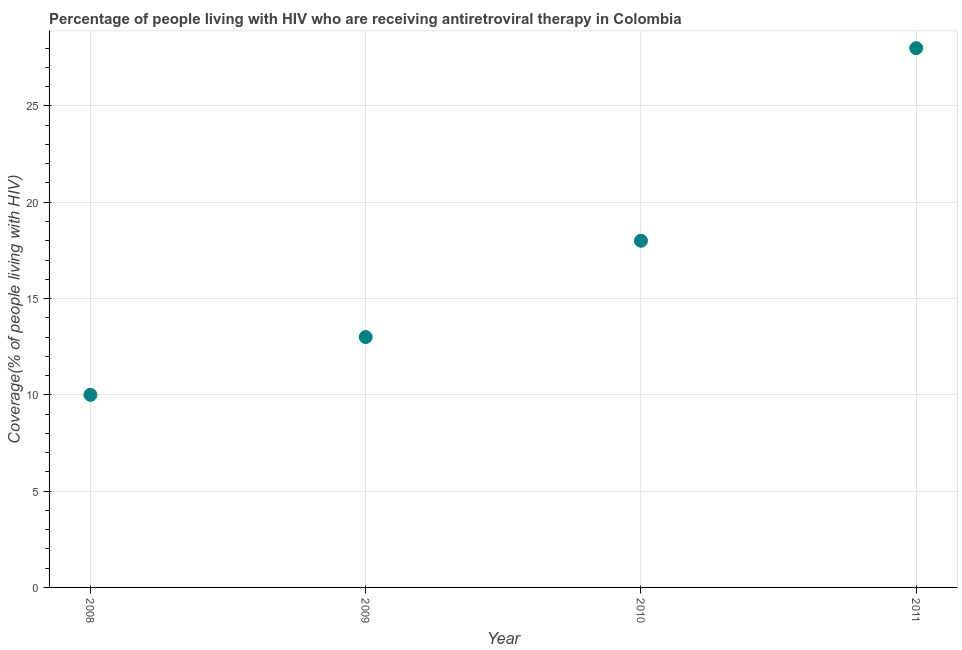What is the antiretroviral therapy coverage in 2008?
Your answer should be compact. 10. Across all years, what is the maximum antiretroviral therapy coverage?
Your answer should be compact. 28. Across all years, what is the minimum antiretroviral therapy coverage?
Offer a terse response. 10. What is the sum of the antiretroviral therapy coverage?
Keep it short and to the point. 69. What is the difference between the antiretroviral therapy coverage in 2008 and 2009?
Offer a terse response. -3. What is the average antiretroviral therapy coverage per year?
Make the answer very short. 17.25. What is the median antiretroviral therapy coverage?
Your answer should be very brief. 15.5. Do a majority of the years between 2010 and 2011 (inclusive) have antiretroviral therapy coverage greater than 18 %?
Offer a terse response. No. What is the ratio of the antiretroviral therapy coverage in 2008 to that in 2010?
Offer a very short reply. 0.56. Is the difference between the antiretroviral therapy coverage in 2008 and 2011 greater than the difference between any two years?
Ensure brevity in your answer.  Yes. What is the difference between the highest and the second highest antiretroviral therapy coverage?
Provide a succinct answer. 10. What is the difference between the highest and the lowest antiretroviral therapy coverage?
Provide a succinct answer. 18. Does the antiretroviral therapy coverage monotonically increase over the years?
Offer a terse response. Yes. How many dotlines are there?
Your answer should be very brief. 1. What is the difference between two consecutive major ticks on the Y-axis?
Your answer should be very brief. 5. Are the values on the major ticks of Y-axis written in scientific E-notation?
Ensure brevity in your answer.  No. Does the graph contain any zero values?
Your response must be concise. No. Does the graph contain grids?
Provide a succinct answer. Yes. What is the title of the graph?
Keep it short and to the point. Percentage of people living with HIV who are receiving antiretroviral therapy in Colombia. What is the label or title of the Y-axis?
Your answer should be very brief. Coverage(% of people living with HIV). What is the Coverage(% of people living with HIV) in 2008?
Ensure brevity in your answer.  10. What is the Coverage(% of people living with HIV) in 2009?
Your response must be concise. 13. What is the Coverage(% of people living with HIV) in 2011?
Offer a terse response. 28. What is the difference between the Coverage(% of people living with HIV) in 2008 and 2009?
Ensure brevity in your answer.  -3. What is the difference between the Coverage(% of people living with HIV) in 2008 and 2011?
Provide a short and direct response. -18. What is the difference between the Coverage(% of people living with HIV) in 2009 and 2011?
Your answer should be very brief. -15. What is the difference between the Coverage(% of people living with HIV) in 2010 and 2011?
Offer a terse response. -10. What is the ratio of the Coverage(% of people living with HIV) in 2008 to that in 2009?
Make the answer very short. 0.77. What is the ratio of the Coverage(% of people living with HIV) in 2008 to that in 2010?
Give a very brief answer. 0.56. What is the ratio of the Coverage(% of people living with HIV) in 2008 to that in 2011?
Make the answer very short. 0.36. What is the ratio of the Coverage(% of people living with HIV) in 2009 to that in 2010?
Your response must be concise. 0.72. What is the ratio of the Coverage(% of people living with HIV) in 2009 to that in 2011?
Provide a succinct answer. 0.46. What is the ratio of the Coverage(% of people living with HIV) in 2010 to that in 2011?
Give a very brief answer. 0.64. 